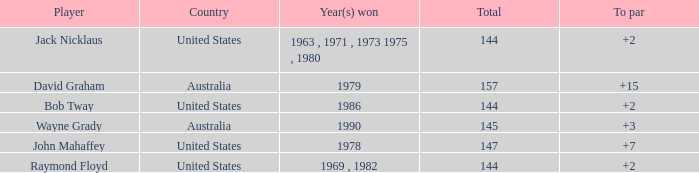How many strokes off par was the winner in 1978? 7.0. 